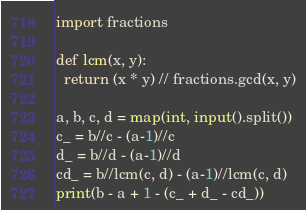Convert code to text. <code><loc_0><loc_0><loc_500><loc_500><_Python_>import fractions

def lcm(x, y):
  return (x * y) // fractions.gcd(x, y)

a, b, c, d = map(int, input().split())
c_ = b//c - (a-1)//c
d_ = b//d - (a-1)//d
cd_ = b//lcm(c, d) - (a-1)//lcm(c, d)
print(b - a + 1 - (c_ + d_ - cd_))</code> 